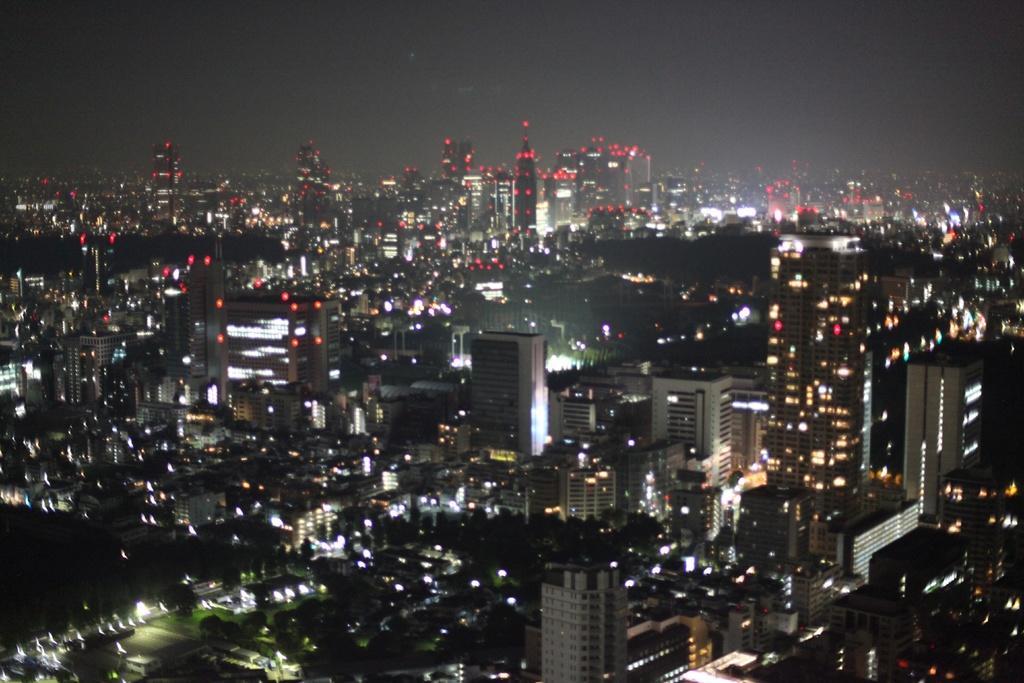Can you describe this image briefly? In this picture there are buildings and lights in the center of the image, it seems to be the picture is captured during night time. 